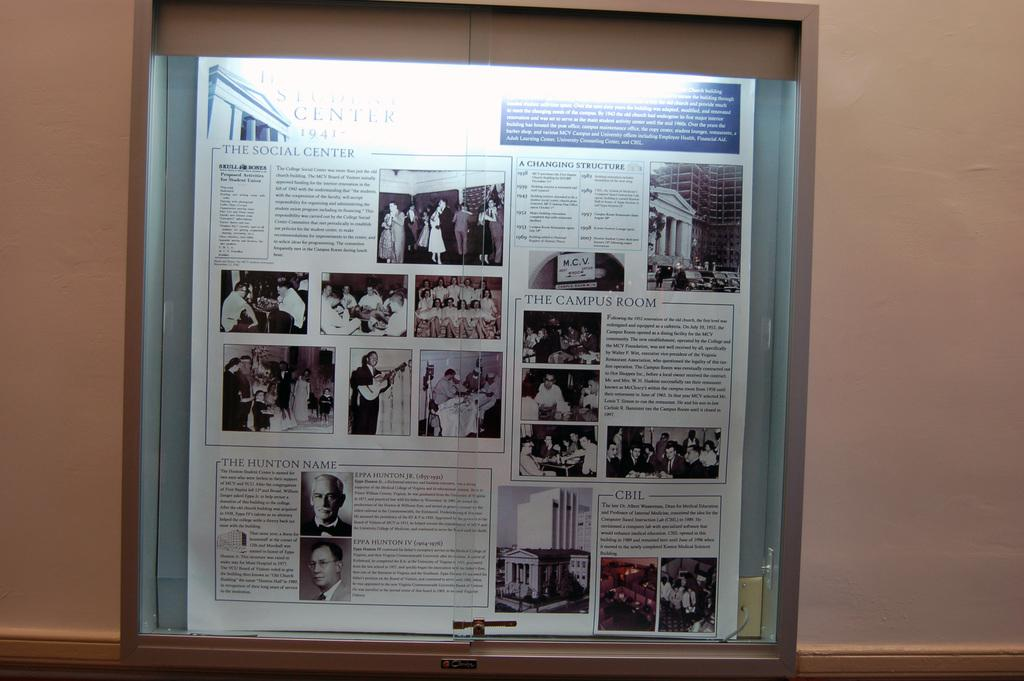<image>
Create a compact narrative representing the image presented. The year of the book states it's from 1941. 